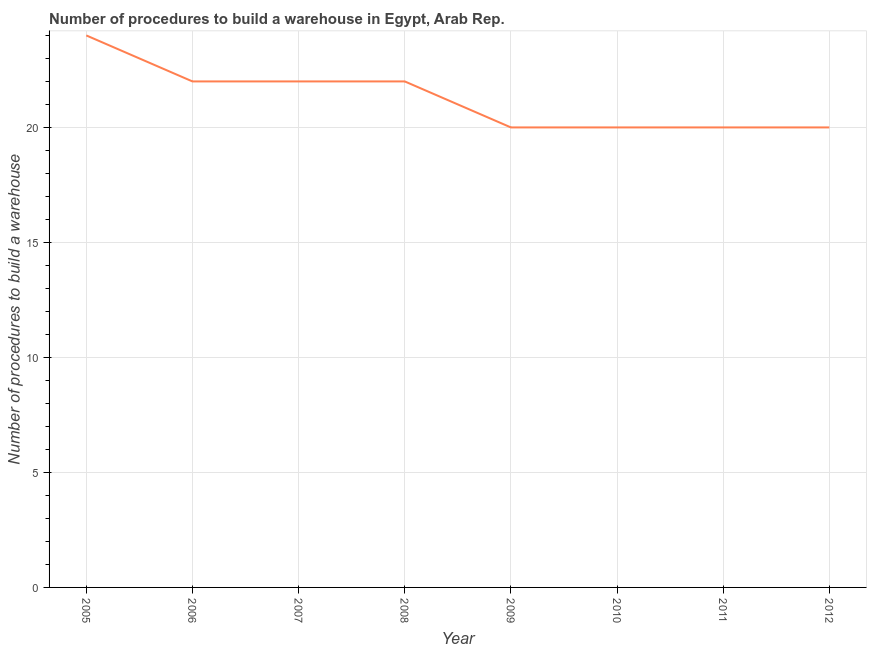What is the number of procedures to build a warehouse in 2009?
Your response must be concise. 20. Across all years, what is the maximum number of procedures to build a warehouse?
Offer a terse response. 24. Across all years, what is the minimum number of procedures to build a warehouse?
Provide a succinct answer. 20. In which year was the number of procedures to build a warehouse minimum?
Your answer should be very brief. 2009. What is the sum of the number of procedures to build a warehouse?
Your answer should be compact. 170. What is the difference between the number of procedures to build a warehouse in 2007 and 2010?
Ensure brevity in your answer.  2. What is the average number of procedures to build a warehouse per year?
Your answer should be compact. 21.25. What is the median number of procedures to build a warehouse?
Offer a terse response. 21. In how many years, is the number of procedures to build a warehouse greater than 19 ?
Offer a terse response. 8. Do a majority of the years between 2010 and 2008 (inclusive) have number of procedures to build a warehouse greater than 5 ?
Keep it short and to the point. No. What is the difference between the highest and the second highest number of procedures to build a warehouse?
Your answer should be compact. 2. Is the sum of the number of procedures to build a warehouse in 2008 and 2012 greater than the maximum number of procedures to build a warehouse across all years?
Provide a succinct answer. Yes. What is the difference between the highest and the lowest number of procedures to build a warehouse?
Provide a short and direct response. 4. Does the number of procedures to build a warehouse monotonically increase over the years?
Offer a very short reply. No. How many lines are there?
Your answer should be very brief. 1. How many years are there in the graph?
Make the answer very short. 8. Are the values on the major ticks of Y-axis written in scientific E-notation?
Your response must be concise. No. Does the graph contain any zero values?
Keep it short and to the point. No. What is the title of the graph?
Offer a terse response. Number of procedures to build a warehouse in Egypt, Arab Rep. What is the label or title of the Y-axis?
Your answer should be very brief. Number of procedures to build a warehouse. What is the Number of procedures to build a warehouse in 2005?
Make the answer very short. 24. What is the Number of procedures to build a warehouse of 2006?
Provide a short and direct response. 22. What is the Number of procedures to build a warehouse of 2007?
Your answer should be very brief. 22. What is the Number of procedures to build a warehouse in 2010?
Keep it short and to the point. 20. What is the Number of procedures to build a warehouse in 2011?
Give a very brief answer. 20. What is the Number of procedures to build a warehouse of 2012?
Make the answer very short. 20. What is the difference between the Number of procedures to build a warehouse in 2005 and 2006?
Make the answer very short. 2. What is the difference between the Number of procedures to build a warehouse in 2005 and 2008?
Offer a very short reply. 2. What is the difference between the Number of procedures to build a warehouse in 2005 and 2011?
Offer a terse response. 4. What is the difference between the Number of procedures to build a warehouse in 2005 and 2012?
Keep it short and to the point. 4. What is the difference between the Number of procedures to build a warehouse in 2006 and 2007?
Your response must be concise. 0. What is the difference between the Number of procedures to build a warehouse in 2006 and 2008?
Your answer should be very brief. 0. What is the difference between the Number of procedures to build a warehouse in 2006 and 2010?
Your answer should be very brief. 2. What is the difference between the Number of procedures to build a warehouse in 2007 and 2008?
Your answer should be compact. 0. What is the difference between the Number of procedures to build a warehouse in 2007 and 2009?
Ensure brevity in your answer.  2. What is the difference between the Number of procedures to build a warehouse in 2007 and 2012?
Your response must be concise. 2. What is the difference between the Number of procedures to build a warehouse in 2008 and 2011?
Offer a terse response. 2. What is the difference between the Number of procedures to build a warehouse in 2009 and 2012?
Your response must be concise. 0. What is the difference between the Number of procedures to build a warehouse in 2010 and 2011?
Your answer should be very brief. 0. What is the difference between the Number of procedures to build a warehouse in 2011 and 2012?
Offer a terse response. 0. What is the ratio of the Number of procedures to build a warehouse in 2005 to that in 2006?
Ensure brevity in your answer.  1.09. What is the ratio of the Number of procedures to build a warehouse in 2005 to that in 2007?
Your answer should be compact. 1.09. What is the ratio of the Number of procedures to build a warehouse in 2005 to that in 2008?
Keep it short and to the point. 1.09. What is the ratio of the Number of procedures to build a warehouse in 2005 to that in 2010?
Offer a terse response. 1.2. What is the ratio of the Number of procedures to build a warehouse in 2005 to that in 2011?
Your response must be concise. 1.2. What is the ratio of the Number of procedures to build a warehouse in 2005 to that in 2012?
Provide a succinct answer. 1.2. What is the ratio of the Number of procedures to build a warehouse in 2006 to that in 2007?
Your answer should be compact. 1. What is the ratio of the Number of procedures to build a warehouse in 2006 to that in 2010?
Provide a succinct answer. 1.1. What is the ratio of the Number of procedures to build a warehouse in 2008 to that in 2009?
Your answer should be compact. 1.1. What is the ratio of the Number of procedures to build a warehouse in 2008 to that in 2010?
Keep it short and to the point. 1.1. What is the ratio of the Number of procedures to build a warehouse in 2008 to that in 2012?
Offer a terse response. 1.1. What is the ratio of the Number of procedures to build a warehouse in 2009 to that in 2011?
Offer a very short reply. 1. What is the ratio of the Number of procedures to build a warehouse in 2010 to that in 2011?
Give a very brief answer. 1. 